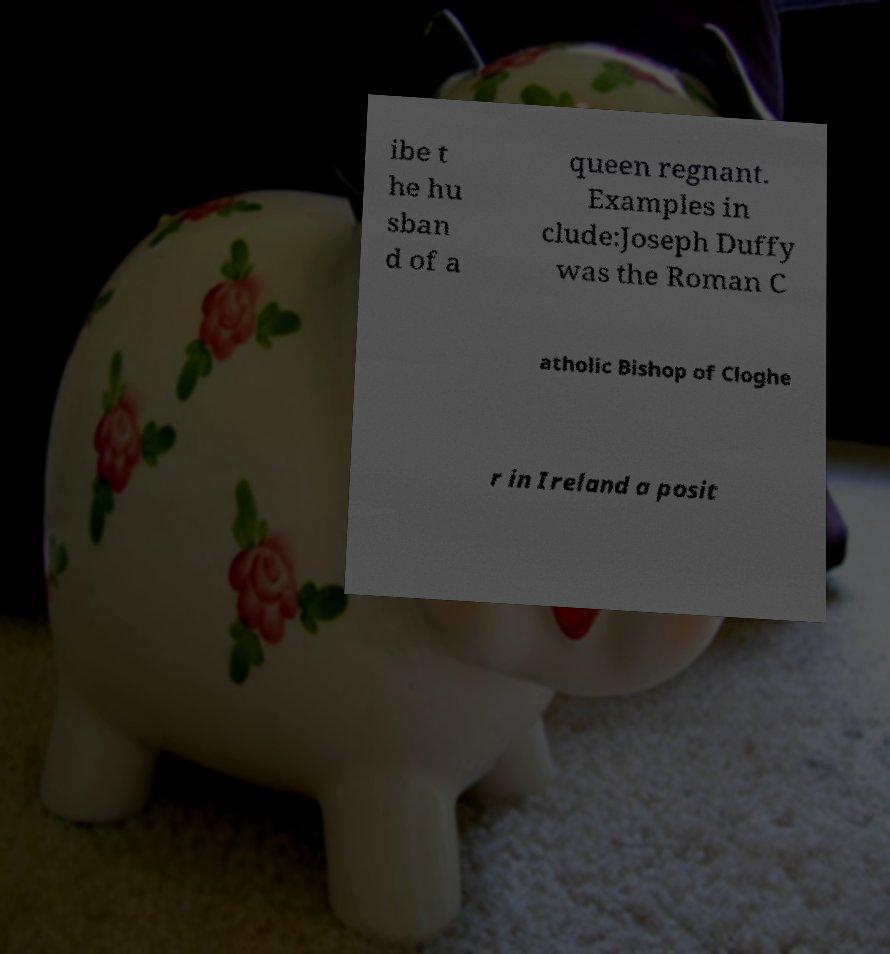There's text embedded in this image that I need extracted. Can you transcribe it verbatim? ibe t he hu sban d of a queen regnant. Examples in clude:Joseph Duffy was the Roman C atholic Bishop of Cloghe r in Ireland a posit 